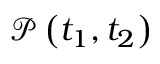Convert formula to latex. <formula><loc_0><loc_0><loc_500><loc_500>\mathcal { P } \left ( t _ { 1 } , t _ { 2 } \right )</formula> 